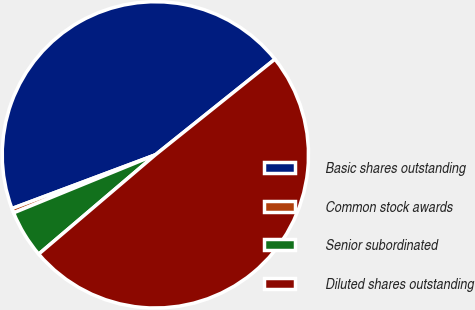Convert chart to OTSL. <chart><loc_0><loc_0><loc_500><loc_500><pie_chart><fcel>Basic shares outstanding<fcel>Common stock awards<fcel>Senior subordinated<fcel>Diluted shares outstanding<nl><fcel>44.96%<fcel>0.48%<fcel>5.04%<fcel>49.52%<nl></chart> 